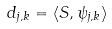Convert formula to latex. <formula><loc_0><loc_0><loc_500><loc_500>d _ { j , k } = \langle S , \psi _ { j , k } \rangle</formula> 